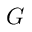Convert formula to latex. <formula><loc_0><loc_0><loc_500><loc_500>G</formula> 